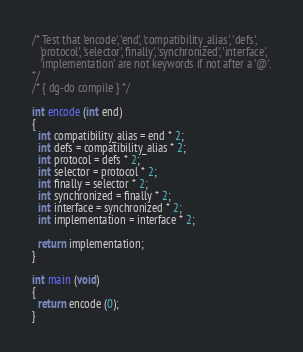<code> <loc_0><loc_0><loc_500><loc_500><_ObjectiveC_>/* Test that 'encode', 'end', 'compatibility_alias', 'defs',
   'protocol', 'selector', finally', 'synchronized', 'interface',
   'implementation' are not keywords if not after a '@'.
*/
/* { dg-do compile } */

int encode (int end)
{
  int compatibility_alias = end * 2;
  int defs = compatibility_alias * 2;
  int protocol = defs * 2;
  int selector = protocol * 2;
  int finally = selector * 2;
  int synchronized = finally * 2;
  int interface = synchronized * 2;
  int implementation = interface * 2;

  return implementation;
}

int main (void)
{
  return encode (0);
}
</code> 